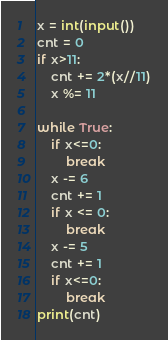<code> <loc_0><loc_0><loc_500><loc_500><_Python_>x = int(input())
cnt = 0
if x>11:
    cnt += 2*(x//11)
    x %= 11

while True:
    if x<=0:
        break
    x -= 6
    cnt += 1
    if x <= 0:
        break
    x -= 5
    cnt += 1
    if x<=0:
        break
print(cnt)</code> 